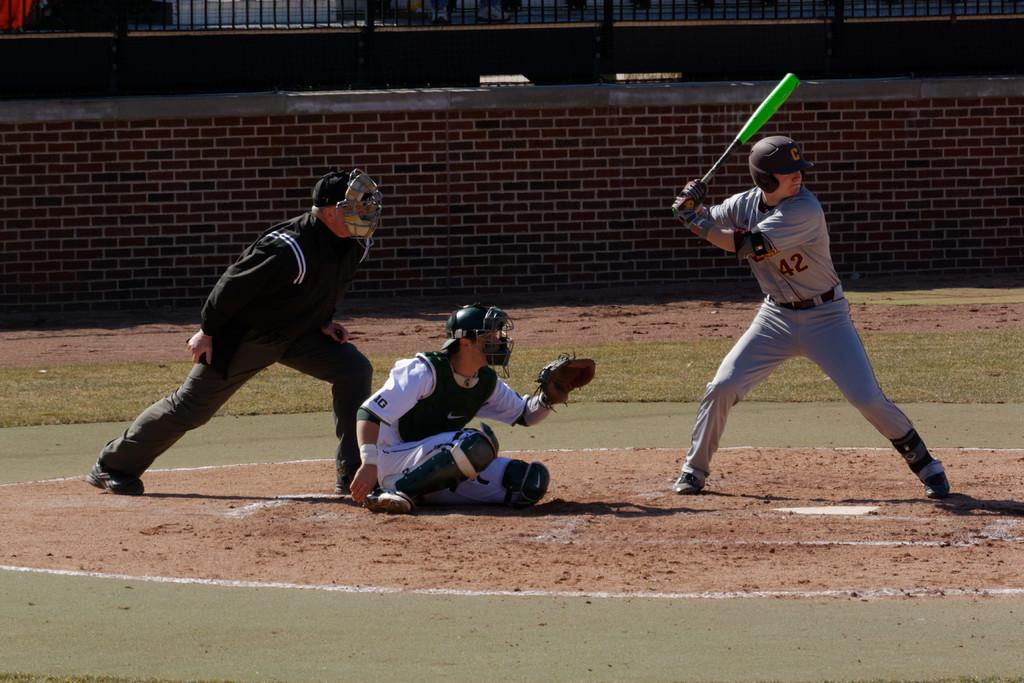What is the shirt number of the batter on the right?
Ensure brevity in your answer.  42. What numbers are visible on the catcher's sleeve?
Offer a terse response. 10. 